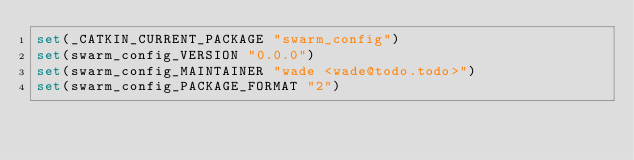<code> <loc_0><loc_0><loc_500><loc_500><_CMake_>set(_CATKIN_CURRENT_PACKAGE "swarm_config")
set(swarm_config_VERSION "0.0.0")
set(swarm_config_MAINTAINER "wade <wade@todo.todo>")
set(swarm_config_PACKAGE_FORMAT "2")</code> 